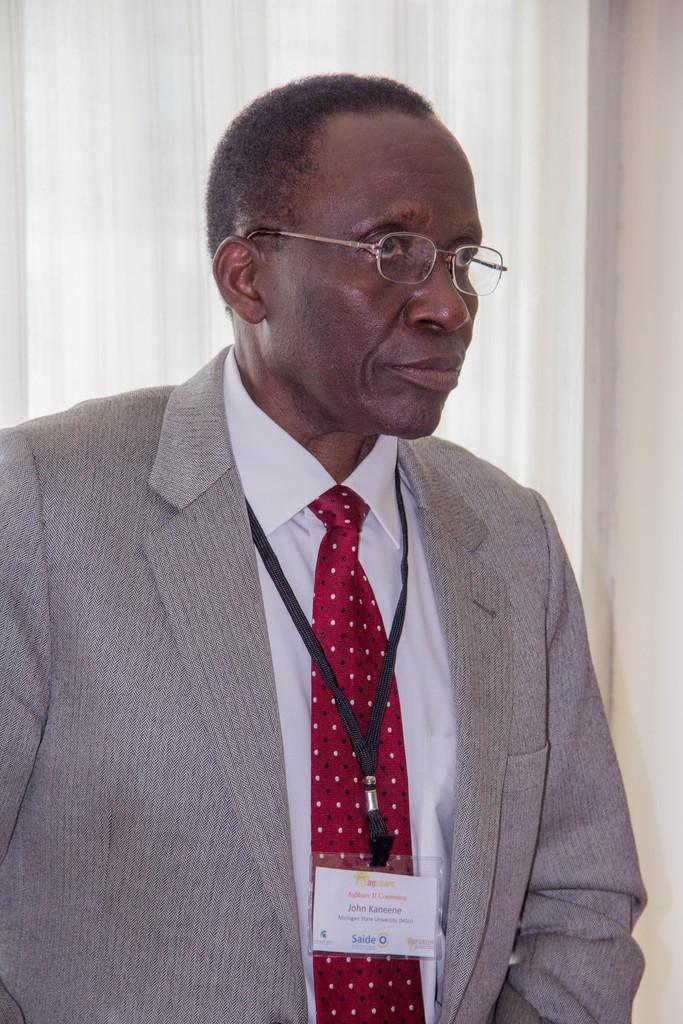What is the main subject in the image? There is a person standing in the image. Can you describe the background of the image? There are curtains in the background of the image. What type of rings does the person have on their fingers in the image? There is no information about rings or any jewelry on the person's fingers in the image. 